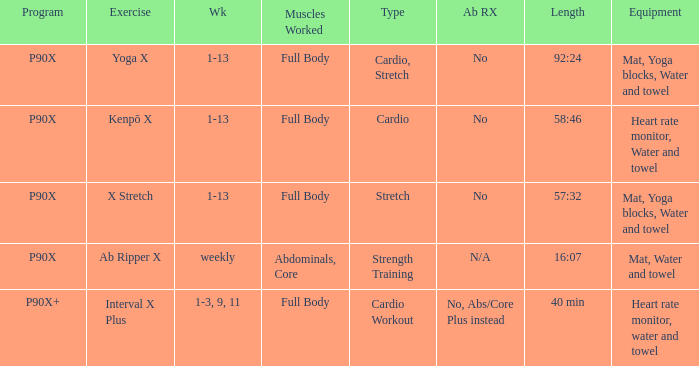What is the week when type is cardio workout? 1-3, 9, 11. 